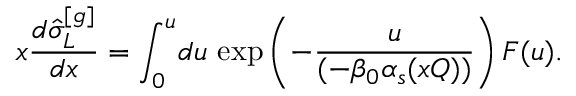<formula> <loc_0><loc_0><loc_500><loc_500>x \frac { d \hat { \sigma } _ { L } ^ { [ g ] } } { d x } = \int _ { 0 } ^ { u } \, d u \, \exp \left ( - \frac { u } { ( - \beta _ { 0 } \alpha _ { s } ( x Q ) ) } \right ) F ( u ) .</formula> 